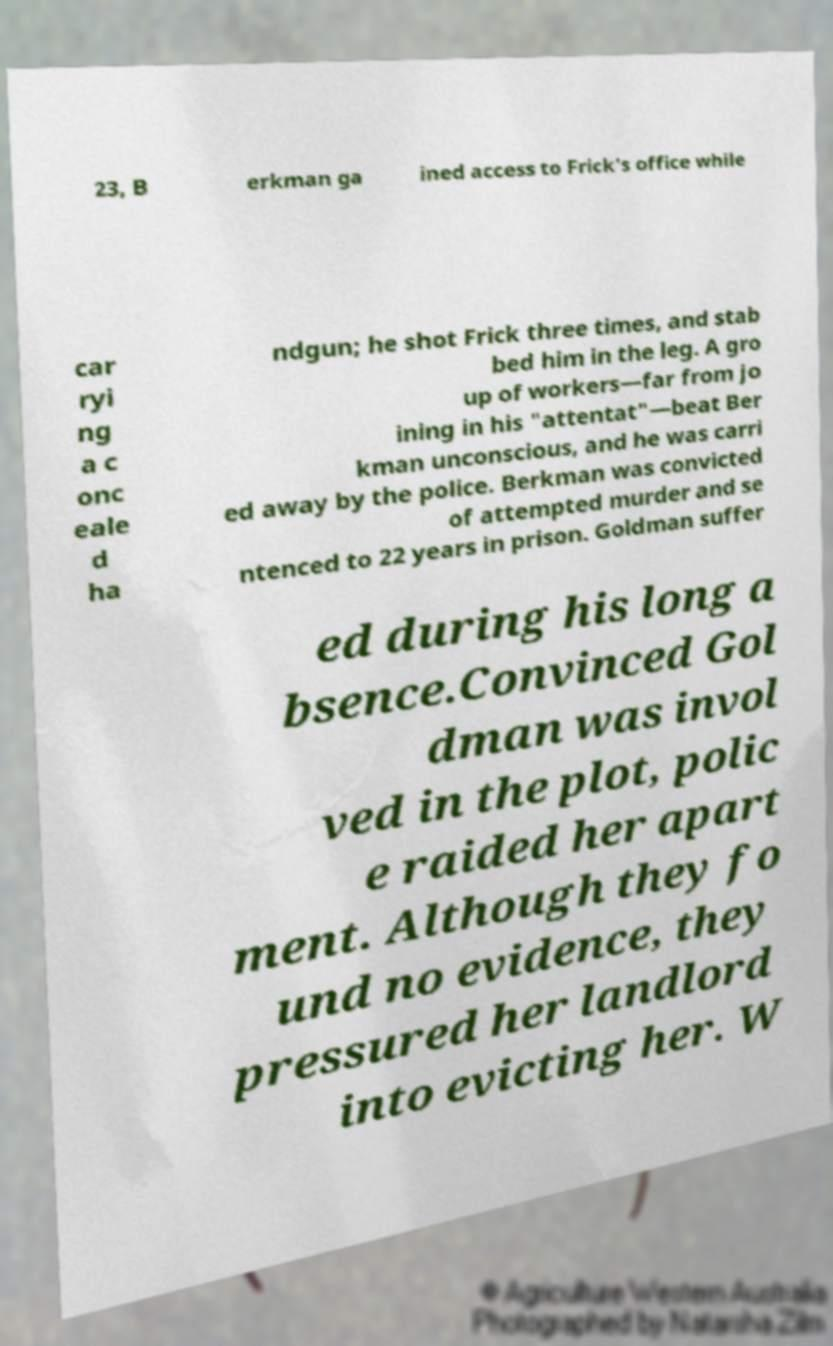Can you read and provide the text displayed in the image?This photo seems to have some interesting text. Can you extract and type it out for me? 23, B erkman ga ined access to Frick's office while car ryi ng a c onc eale d ha ndgun; he shot Frick three times, and stab bed him in the leg. A gro up of workers—far from jo ining in his "attentat"—beat Ber kman unconscious, and he was carri ed away by the police. Berkman was convicted of attempted murder and se ntenced to 22 years in prison. Goldman suffer ed during his long a bsence.Convinced Gol dman was invol ved in the plot, polic e raided her apart ment. Although they fo und no evidence, they pressured her landlord into evicting her. W 